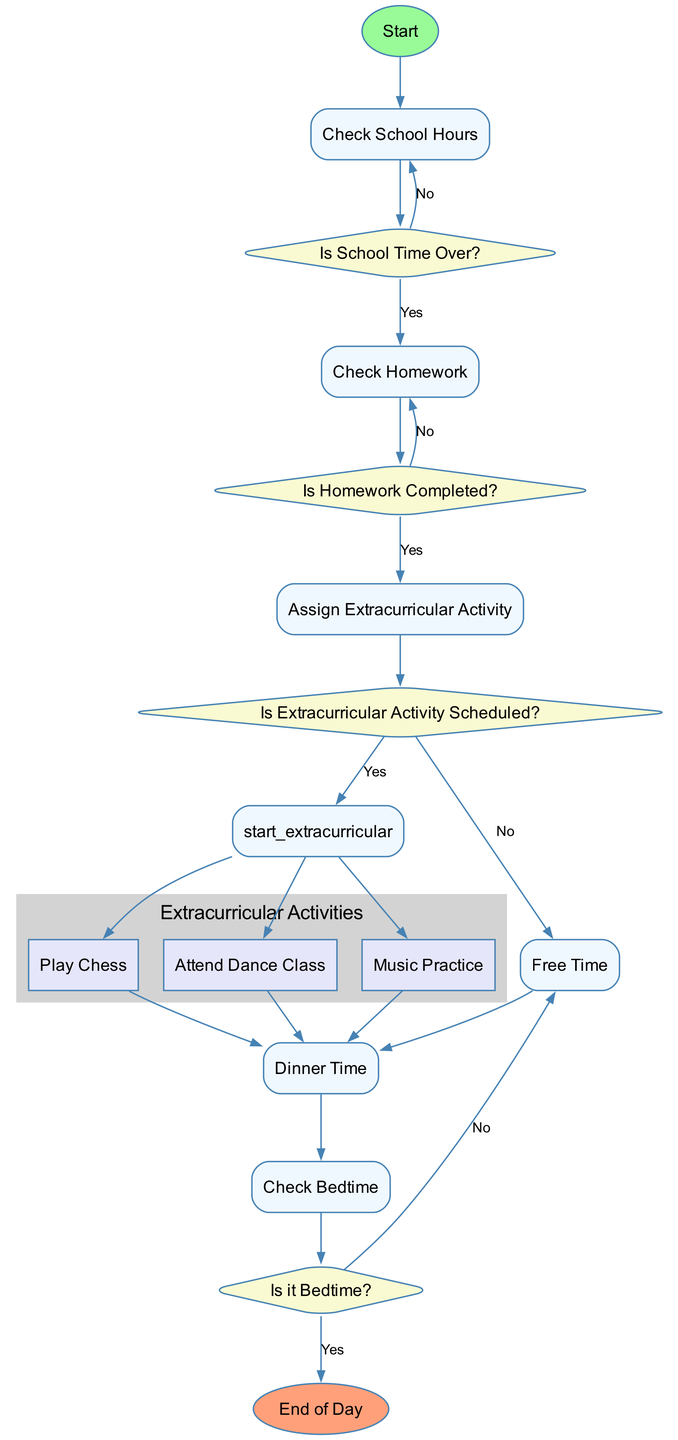What is the first node in the flowchart? The flowchart begins with the "Start" node, indicating the starting point of the process.
Answer: Start How many edges lead from the "Check Homework" node? From the "Check Homework" node, there are two edges leading to the "Is Homework Completed?" decision, indicating the two possible outcomes: completed or not completed.
Answer: 2 What is the label of the decision node after checking school hours? The decision node that follows checking school hours is labeled "Is School Time Over?", which determines whether the child should check homework.
Answer: Is School Time Over? If homework is not completed, what is the next step? If the homework is not completed, the flowchart indicates that the next action is to "Complete Homework" before moving on to extracurricular activities.
Answer: Complete Homework How many extracurricular activities are listed in the diagram? There are three extracurricular activities listed in the diagram: Play Chess, Attend Dance Class, and Music Practice, providing options for the child after homework completion.
Answer: 3 What happens if it is not bedtime after dinner time? If it is not bedtime after dinner time, the flowchart allows for "Free Play or Reading", indicating that the child can engage in these activities before going to bed.
Answer: Free Play or Reading What is the outcome if the extracurricular activity is not scheduled? If the extracurricular activity is not scheduled, the flowchart directs to "Free Time", indicating that the child has time for unstructured activities.
Answer: Free Time What node follows the "Start Extracurricular Activity" node? After the "Start Extracurricular Activity" node, several activities are listed, specifically: Play Chess, Attend Dance Class, and Music Practice, which represent the options available to the child.
Answer: Play Chess, Attend Dance Class, Music Practice What is the final node in the flowchart? The final node in the flowchart is labeled "End of Day", signifying the conclusion of the child's daily schedule.
Answer: End of Day 